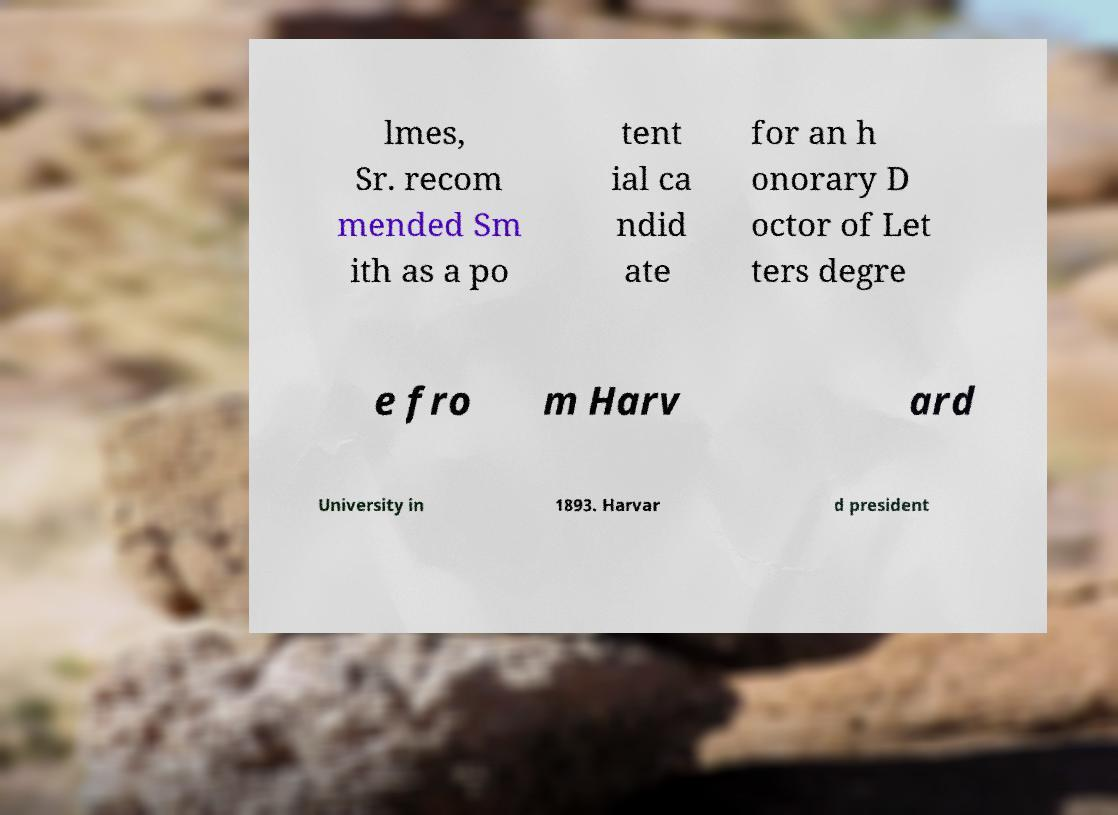I need the written content from this picture converted into text. Can you do that? lmes, Sr. recom mended Sm ith as a po tent ial ca ndid ate for an h onorary D octor of Let ters degre e fro m Harv ard University in 1893. Harvar d president 